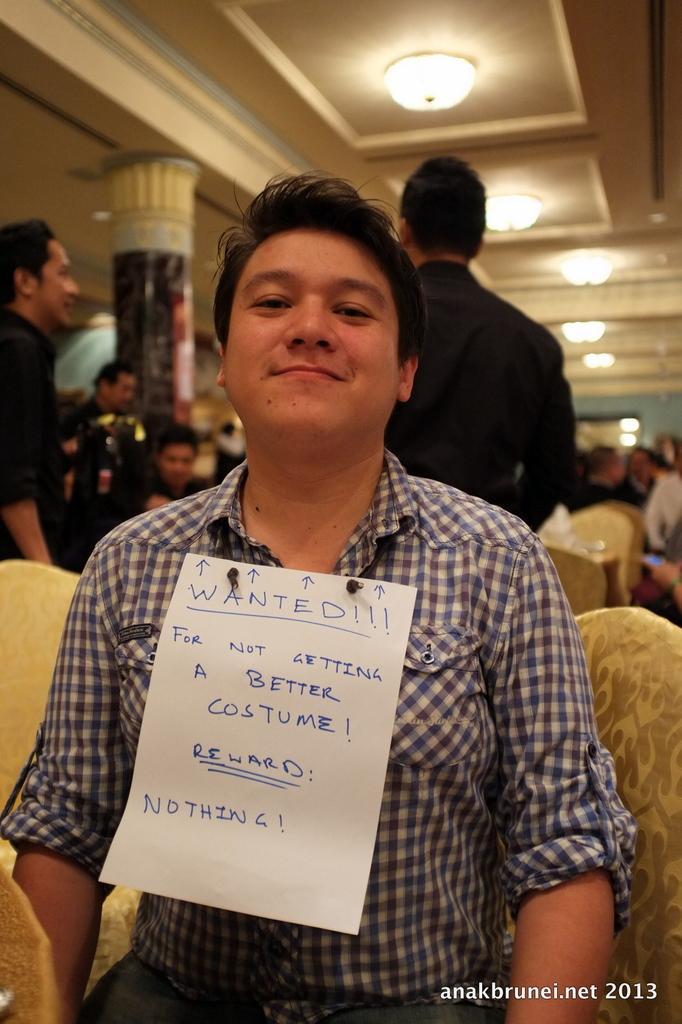In one or two sentences, can you explain what this image depicts? This picture seems to be clicked inside the hall. In the foreground we can see a person wearing shirt and sitting on the chair and we can see the text on the paper which is attached to the shirt of a person. In the background we can see the roof, lights, group of people, chairs, pillar and many other objects. In the bottom right corner there is a watermark on the image. 